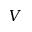<formula> <loc_0><loc_0><loc_500><loc_500>V</formula> 